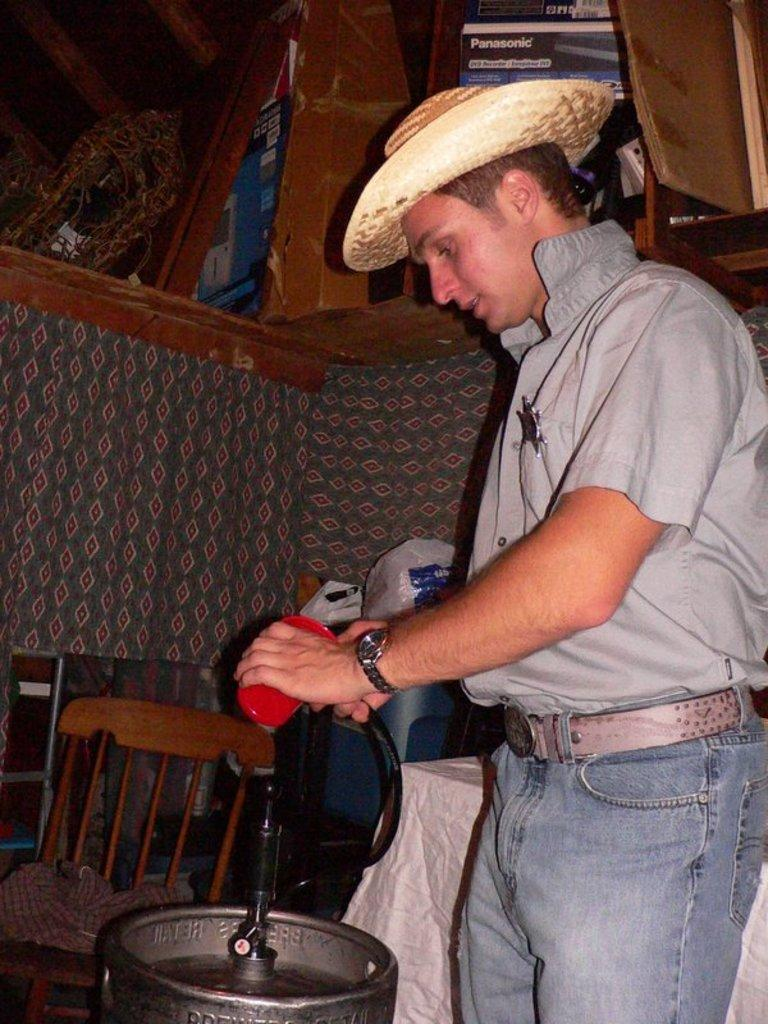What is the man in the image doing? The image shows a man standing. What is the man wearing on his upper body? The man is wearing a grey shirt. Is the man wearing any headgear in the image? Yes, the man is wearing a hat. What object is beside the man? There is a chair beside the man. What can be seen in front of the man? There is an instrument in front of the man. What month is depicted in the image? There is no month depicted in the image; it is a still photograph of a man standing. 